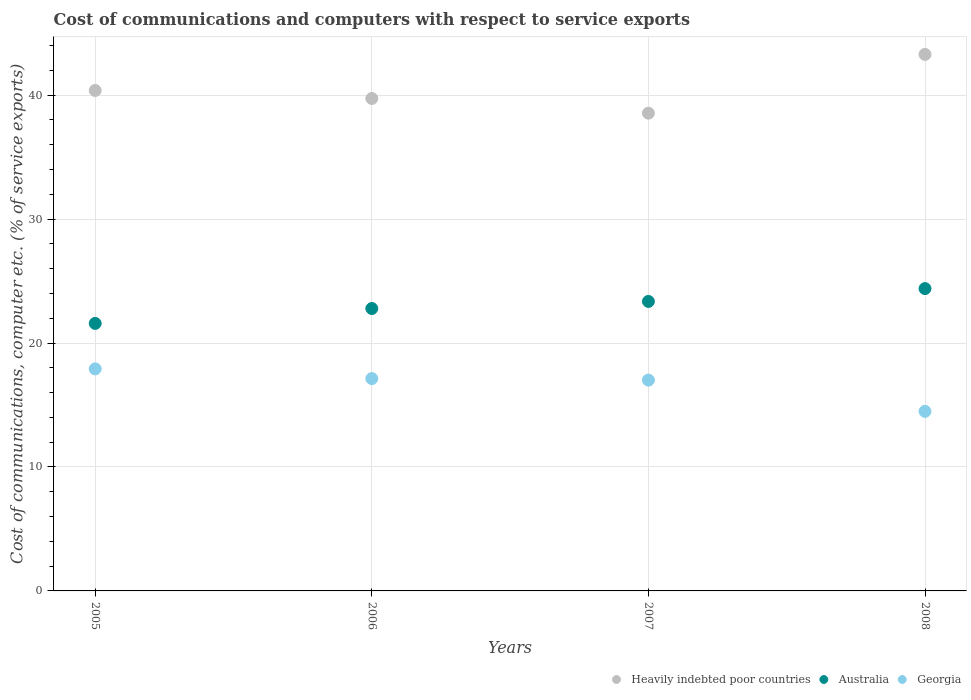How many different coloured dotlines are there?
Give a very brief answer. 3. What is the cost of communications and computers in Heavily indebted poor countries in 2006?
Your answer should be compact. 39.73. Across all years, what is the maximum cost of communications and computers in Australia?
Ensure brevity in your answer.  24.39. Across all years, what is the minimum cost of communications and computers in Georgia?
Your answer should be compact. 14.49. What is the total cost of communications and computers in Heavily indebted poor countries in the graph?
Offer a very short reply. 161.94. What is the difference between the cost of communications and computers in Georgia in 2005 and that in 2006?
Your answer should be very brief. 0.78. What is the difference between the cost of communications and computers in Georgia in 2008 and the cost of communications and computers in Australia in 2007?
Provide a short and direct response. -8.87. What is the average cost of communications and computers in Australia per year?
Offer a terse response. 23.03. In the year 2006, what is the difference between the cost of communications and computers in Heavily indebted poor countries and cost of communications and computers in Australia?
Your response must be concise. 16.95. What is the ratio of the cost of communications and computers in Georgia in 2005 to that in 2006?
Ensure brevity in your answer.  1.05. What is the difference between the highest and the second highest cost of communications and computers in Australia?
Ensure brevity in your answer.  1.04. What is the difference between the highest and the lowest cost of communications and computers in Australia?
Your response must be concise. 2.81. How many dotlines are there?
Your response must be concise. 3. Are the values on the major ticks of Y-axis written in scientific E-notation?
Keep it short and to the point. No. Does the graph contain grids?
Offer a terse response. Yes. Where does the legend appear in the graph?
Your answer should be compact. Bottom right. How many legend labels are there?
Offer a very short reply. 3. How are the legend labels stacked?
Offer a very short reply. Horizontal. What is the title of the graph?
Offer a very short reply. Cost of communications and computers with respect to service exports. Does "Romania" appear as one of the legend labels in the graph?
Your response must be concise. No. What is the label or title of the X-axis?
Your response must be concise. Years. What is the label or title of the Y-axis?
Provide a succinct answer. Cost of communications, computer etc. (% of service exports). What is the Cost of communications, computer etc. (% of service exports) in Heavily indebted poor countries in 2005?
Offer a terse response. 40.38. What is the Cost of communications, computer etc. (% of service exports) in Australia in 2005?
Your answer should be very brief. 21.58. What is the Cost of communications, computer etc. (% of service exports) in Georgia in 2005?
Offer a very short reply. 17.92. What is the Cost of communications, computer etc. (% of service exports) in Heavily indebted poor countries in 2006?
Ensure brevity in your answer.  39.73. What is the Cost of communications, computer etc. (% of service exports) of Australia in 2006?
Make the answer very short. 22.79. What is the Cost of communications, computer etc. (% of service exports) of Georgia in 2006?
Your answer should be compact. 17.13. What is the Cost of communications, computer etc. (% of service exports) of Heavily indebted poor countries in 2007?
Your answer should be very brief. 38.55. What is the Cost of communications, computer etc. (% of service exports) of Australia in 2007?
Your answer should be compact. 23.36. What is the Cost of communications, computer etc. (% of service exports) in Georgia in 2007?
Your answer should be very brief. 17.01. What is the Cost of communications, computer etc. (% of service exports) in Heavily indebted poor countries in 2008?
Offer a very short reply. 43.29. What is the Cost of communications, computer etc. (% of service exports) in Australia in 2008?
Provide a succinct answer. 24.39. What is the Cost of communications, computer etc. (% of service exports) in Georgia in 2008?
Keep it short and to the point. 14.49. Across all years, what is the maximum Cost of communications, computer etc. (% of service exports) in Heavily indebted poor countries?
Provide a short and direct response. 43.29. Across all years, what is the maximum Cost of communications, computer etc. (% of service exports) of Australia?
Your answer should be compact. 24.39. Across all years, what is the maximum Cost of communications, computer etc. (% of service exports) of Georgia?
Your answer should be compact. 17.92. Across all years, what is the minimum Cost of communications, computer etc. (% of service exports) of Heavily indebted poor countries?
Your response must be concise. 38.55. Across all years, what is the minimum Cost of communications, computer etc. (% of service exports) of Australia?
Your answer should be compact. 21.58. Across all years, what is the minimum Cost of communications, computer etc. (% of service exports) of Georgia?
Ensure brevity in your answer.  14.49. What is the total Cost of communications, computer etc. (% of service exports) in Heavily indebted poor countries in the graph?
Offer a very short reply. 161.94. What is the total Cost of communications, computer etc. (% of service exports) in Australia in the graph?
Give a very brief answer. 92.12. What is the total Cost of communications, computer etc. (% of service exports) of Georgia in the graph?
Make the answer very short. 66.55. What is the difference between the Cost of communications, computer etc. (% of service exports) of Heavily indebted poor countries in 2005 and that in 2006?
Offer a very short reply. 0.64. What is the difference between the Cost of communications, computer etc. (% of service exports) in Australia in 2005 and that in 2006?
Offer a terse response. -1.2. What is the difference between the Cost of communications, computer etc. (% of service exports) in Georgia in 2005 and that in 2006?
Offer a very short reply. 0.78. What is the difference between the Cost of communications, computer etc. (% of service exports) of Heavily indebted poor countries in 2005 and that in 2007?
Provide a succinct answer. 1.83. What is the difference between the Cost of communications, computer etc. (% of service exports) of Australia in 2005 and that in 2007?
Make the answer very short. -1.77. What is the difference between the Cost of communications, computer etc. (% of service exports) of Georgia in 2005 and that in 2007?
Offer a terse response. 0.91. What is the difference between the Cost of communications, computer etc. (% of service exports) of Heavily indebted poor countries in 2005 and that in 2008?
Provide a short and direct response. -2.91. What is the difference between the Cost of communications, computer etc. (% of service exports) in Australia in 2005 and that in 2008?
Provide a short and direct response. -2.81. What is the difference between the Cost of communications, computer etc. (% of service exports) of Georgia in 2005 and that in 2008?
Make the answer very short. 3.43. What is the difference between the Cost of communications, computer etc. (% of service exports) of Heavily indebted poor countries in 2006 and that in 2007?
Ensure brevity in your answer.  1.19. What is the difference between the Cost of communications, computer etc. (% of service exports) in Australia in 2006 and that in 2007?
Your answer should be very brief. -0.57. What is the difference between the Cost of communications, computer etc. (% of service exports) of Georgia in 2006 and that in 2007?
Your response must be concise. 0.12. What is the difference between the Cost of communications, computer etc. (% of service exports) of Heavily indebted poor countries in 2006 and that in 2008?
Your answer should be very brief. -3.55. What is the difference between the Cost of communications, computer etc. (% of service exports) in Australia in 2006 and that in 2008?
Offer a terse response. -1.61. What is the difference between the Cost of communications, computer etc. (% of service exports) of Georgia in 2006 and that in 2008?
Offer a very short reply. 2.65. What is the difference between the Cost of communications, computer etc. (% of service exports) of Heavily indebted poor countries in 2007 and that in 2008?
Provide a short and direct response. -4.74. What is the difference between the Cost of communications, computer etc. (% of service exports) of Australia in 2007 and that in 2008?
Provide a succinct answer. -1.04. What is the difference between the Cost of communications, computer etc. (% of service exports) of Georgia in 2007 and that in 2008?
Keep it short and to the point. 2.52. What is the difference between the Cost of communications, computer etc. (% of service exports) in Heavily indebted poor countries in 2005 and the Cost of communications, computer etc. (% of service exports) in Australia in 2006?
Offer a very short reply. 17.59. What is the difference between the Cost of communications, computer etc. (% of service exports) in Heavily indebted poor countries in 2005 and the Cost of communications, computer etc. (% of service exports) in Georgia in 2006?
Offer a terse response. 23.24. What is the difference between the Cost of communications, computer etc. (% of service exports) in Australia in 2005 and the Cost of communications, computer etc. (% of service exports) in Georgia in 2006?
Your answer should be compact. 4.45. What is the difference between the Cost of communications, computer etc. (% of service exports) in Heavily indebted poor countries in 2005 and the Cost of communications, computer etc. (% of service exports) in Australia in 2007?
Keep it short and to the point. 17.02. What is the difference between the Cost of communications, computer etc. (% of service exports) in Heavily indebted poor countries in 2005 and the Cost of communications, computer etc. (% of service exports) in Georgia in 2007?
Your answer should be compact. 23.37. What is the difference between the Cost of communications, computer etc. (% of service exports) of Australia in 2005 and the Cost of communications, computer etc. (% of service exports) of Georgia in 2007?
Make the answer very short. 4.57. What is the difference between the Cost of communications, computer etc. (% of service exports) of Heavily indebted poor countries in 2005 and the Cost of communications, computer etc. (% of service exports) of Australia in 2008?
Provide a short and direct response. 15.98. What is the difference between the Cost of communications, computer etc. (% of service exports) of Heavily indebted poor countries in 2005 and the Cost of communications, computer etc. (% of service exports) of Georgia in 2008?
Offer a very short reply. 25.89. What is the difference between the Cost of communications, computer etc. (% of service exports) in Australia in 2005 and the Cost of communications, computer etc. (% of service exports) in Georgia in 2008?
Provide a short and direct response. 7.1. What is the difference between the Cost of communications, computer etc. (% of service exports) in Heavily indebted poor countries in 2006 and the Cost of communications, computer etc. (% of service exports) in Australia in 2007?
Provide a short and direct response. 16.38. What is the difference between the Cost of communications, computer etc. (% of service exports) in Heavily indebted poor countries in 2006 and the Cost of communications, computer etc. (% of service exports) in Georgia in 2007?
Your response must be concise. 22.72. What is the difference between the Cost of communications, computer etc. (% of service exports) of Australia in 2006 and the Cost of communications, computer etc. (% of service exports) of Georgia in 2007?
Your answer should be very brief. 5.78. What is the difference between the Cost of communications, computer etc. (% of service exports) of Heavily indebted poor countries in 2006 and the Cost of communications, computer etc. (% of service exports) of Australia in 2008?
Your response must be concise. 15.34. What is the difference between the Cost of communications, computer etc. (% of service exports) of Heavily indebted poor countries in 2006 and the Cost of communications, computer etc. (% of service exports) of Georgia in 2008?
Provide a short and direct response. 25.24. What is the difference between the Cost of communications, computer etc. (% of service exports) of Australia in 2006 and the Cost of communications, computer etc. (% of service exports) of Georgia in 2008?
Your answer should be very brief. 8.3. What is the difference between the Cost of communications, computer etc. (% of service exports) in Heavily indebted poor countries in 2007 and the Cost of communications, computer etc. (% of service exports) in Australia in 2008?
Keep it short and to the point. 14.15. What is the difference between the Cost of communications, computer etc. (% of service exports) of Heavily indebted poor countries in 2007 and the Cost of communications, computer etc. (% of service exports) of Georgia in 2008?
Offer a very short reply. 24.06. What is the difference between the Cost of communications, computer etc. (% of service exports) of Australia in 2007 and the Cost of communications, computer etc. (% of service exports) of Georgia in 2008?
Offer a terse response. 8.87. What is the average Cost of communications, computer etc. (% of service exports) of Heavily indebted poor countries per year?
Your response must be concise. 40.49. What is the average Cost of communications, computer etc. (% of service exports) in Australia per year?
Make the answer very short. 23.03. What is the average Cost of communications, computer etc. (% of service exports) of Georgia per year?
Ensure brevity in your answer.  16.64. In the year 2005, what is the difference between the Cost of communications, computer etc. (% of service exports) in Heavily indebted poor countries and Cost of communications, computer etc. (% of service exports) in Australia?
Provide a short and direct response. 18.79. In the year 2005, what is the difference between the Cost of communications, computer etc. (% of service exports) of Heavily indebted poor countries and Cost of communications, computer etc. (% of service exports) of Georgia?
Your answer should be very brief. 22.46. In the year 2005, what is the difference between the Cost of communications, computer etc. (% of service exports) of Australia and Cost of communications, computer etc. (% of service exports) of Georgia?
Provide a succinct answer. 3.67. In the year 2006, what is the difference between the Cost of communications, computer etc. (% of service exports) in Heavily indebted poor countries and Cost of communications, computer etc. (% of service exports) in Australia?
Make the answer very short. 16.95. In the year 2006, what is the difference between the Cost of communications, computer etc. (% of service exports) in Heavily indebted poor countries and Cost of communications, computer etc. (% of service exports) in Georgia?
Offer a very short reply. 22.6. In the year 2006, what is the difference between the Cost of communications, computer etc. (% of service exports) of Australia and Cost of communications, computer etc. (% of service exports) of Georgia?
Provide a succinct answer. 5.65. In the year 2007, what is the difference between the Cost of communications, computer etc. (% of service exports) of Heavily indebted poor countries and Cost of communications, computer etc. (% of service exports) of Australia?
Make the answer very short. 15.19. In the year 2007, what is the difference between the Cost of communications, computer etc. (% of service exports) in Heavily indebted poor countries and Cost of communications, computer etc. (% of service exports) in Georgia?
Ensure brevity in your answer.  21.54. In the year 2007, what is the difference between the Cost of communications, computer etc. (% of service exports) of Australia and Cost of communications, computer etc. (% of service exports) of Georgia?
Provide a short and direct response. 6.35. In the year 2008, what is the difference between the Cost of communications, computer etc. (% of service exports) of Heavily indebted poor countries and Cost of communications, computer etc. (% of service exports) of Australia?
Provide a succinct answer. 18.89. In the year 2008, what is the difference between the Cost of communications, computer etc. (% of service exports) of Heavily indebted poor countries and Cost of communications, computer etc. (% of service exports) of Georgia?
Your response must be concise. 28.8. In the year 2008, what is the difference between the Cost of communications, computer etc. (% of service exports) of Australia and Cost of communications, computer etc. (% of service exports) of Georgia?
Your response must be concise. 9.9. What is the ratio of the Cost of communications, computer etc. (% of service exports) of Heavily indebted poor countries in 2005 to that in 2006?
Give a very brief answer. 1.02. What is the ratio of the Cost of communications, computer etc. (% of service exports) in Australia in 2005 to that in 2006?
Make the answer very short. 0.95. What is the ratio of the Cost of communications, computer etc. (% of service exports) in Georgia in 2005 to that in 2006?
Provide a short and direct response. 1.05. What is the ratio of the Cost of communications, computer etc. (% of service exports) of Heavily indebted poor countries in 2005 to that in 2007?
Your response must be concise. 1.05. What is the ratio of the Cost of communications, computer etc. (% of service exports) of Australia in 2005 to that in 2007?
Provide a succinct answer. 0.92. What is the ratio of the Cost of communications, computer etc. (% of service exports) in Georgia in 2005 to that in 2007?
Provide a succinct answer. 1.05. What is the ratio of the Cost of communications, computer etc. (% of service exports) of Heavily indebted poor countries in 2005 to that in 2008?
Provide a succinct answer. 0.93. What is the ratio of the Cost of communications, computer etc. (% of service exports) of Australia in 2005 to that in 2008?
Provide a short and direct response. 0.88. What is the ratio of the Cost of communications, computer etc. (% of service exports) in Georgia in 2005 to that in 2008?
Your answer should be compact. 1.24. What is the ratio of the Cost of communications, computer etc. (% of service exports) in Heavily indebted poor countries in 2006 to that in 2007?
Make the answer very short. 1.03. What is the ratio of the Cost of communications, computer etc. (% of service exports) of Australia in 2006 to that in 2007?
Keep it short and to the point. 0.98. What is the ratio of the Cost of communications, computer etc. (% of service exports) of Georgia in 2006 to that in 2007?
Make the answer very short. 1.01. What is the ratio of the Cost of communications, computer etc. (% of service exports) in Heavily indebted poor countries in 2006 to that in 2008?
Provide a succinct answer. 0.92. What is the ratio of the Cost of communications, computer etc. (% of service exports) in Australia in 2006 to that in 2008?
Offer a terse response. 0.93. What is the ratio of the Cost of communications, computer etc. (% of service exports) of Georgia in 2006 to that in 2008?
Provide a short and direct response. 1.18. What is the ratio of the Cost of communications, computer etc. (% of service exports) of Heavily indebted poor countries in 2007 to that in 2008?
Keep it short and to the point. 0.89. What is the ratio of the Cost of communications, computer etc. (% of service exports) of Australia in 2007 to that in 2008?
Keep it short and to the point. 0.96. What is the ratio of the Cost of communications, computer etc. (% of service exports) of Georgia in 2007 to that in 2008?
Your answer should be very brief. 1.17. What is the difference between the highest and the second highest Cost of communications, computer etc. (% of service exports) of Heavily indebted poor countries?
Ensure brevity in your answer.  2.91. What is the difference between the highest and the second highest Cost of communications, computer etc. (% of service exports) in Australia?
Your answer should be compact. 1.04. What is the difference between the highest and the second highest Cost of communications, computer etc. (% of service exports) of Georgia?
Your answer should be very brief. 0.78. What is the difference between the highest and the lowest Cost of communications, computer etc. (% of service exports) in Heavily indebted poor countries?
Your response must be concise. 4.74. What is the difference between the highest and the lowest Cost of communications, computer etc. (% of service exports) of Australia?
Offer a terse response. 2.81. What is the difference between the highest and the lowest Cost of communications, computer etc. (% of service exports) in Georgia?
Offer a terse response. 3.43. 